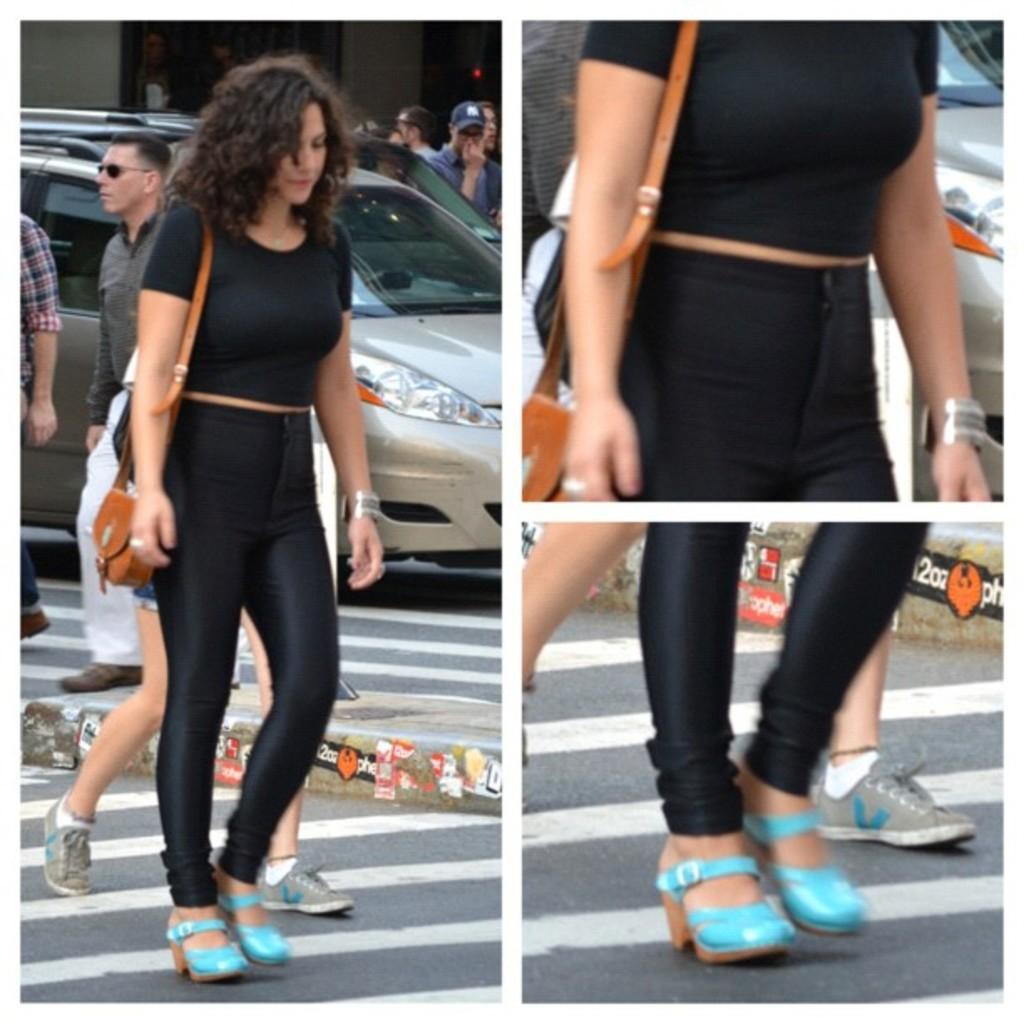Describe this image in one or two sentences. This picture describes about collage of images, in this we can find few people and a car. 